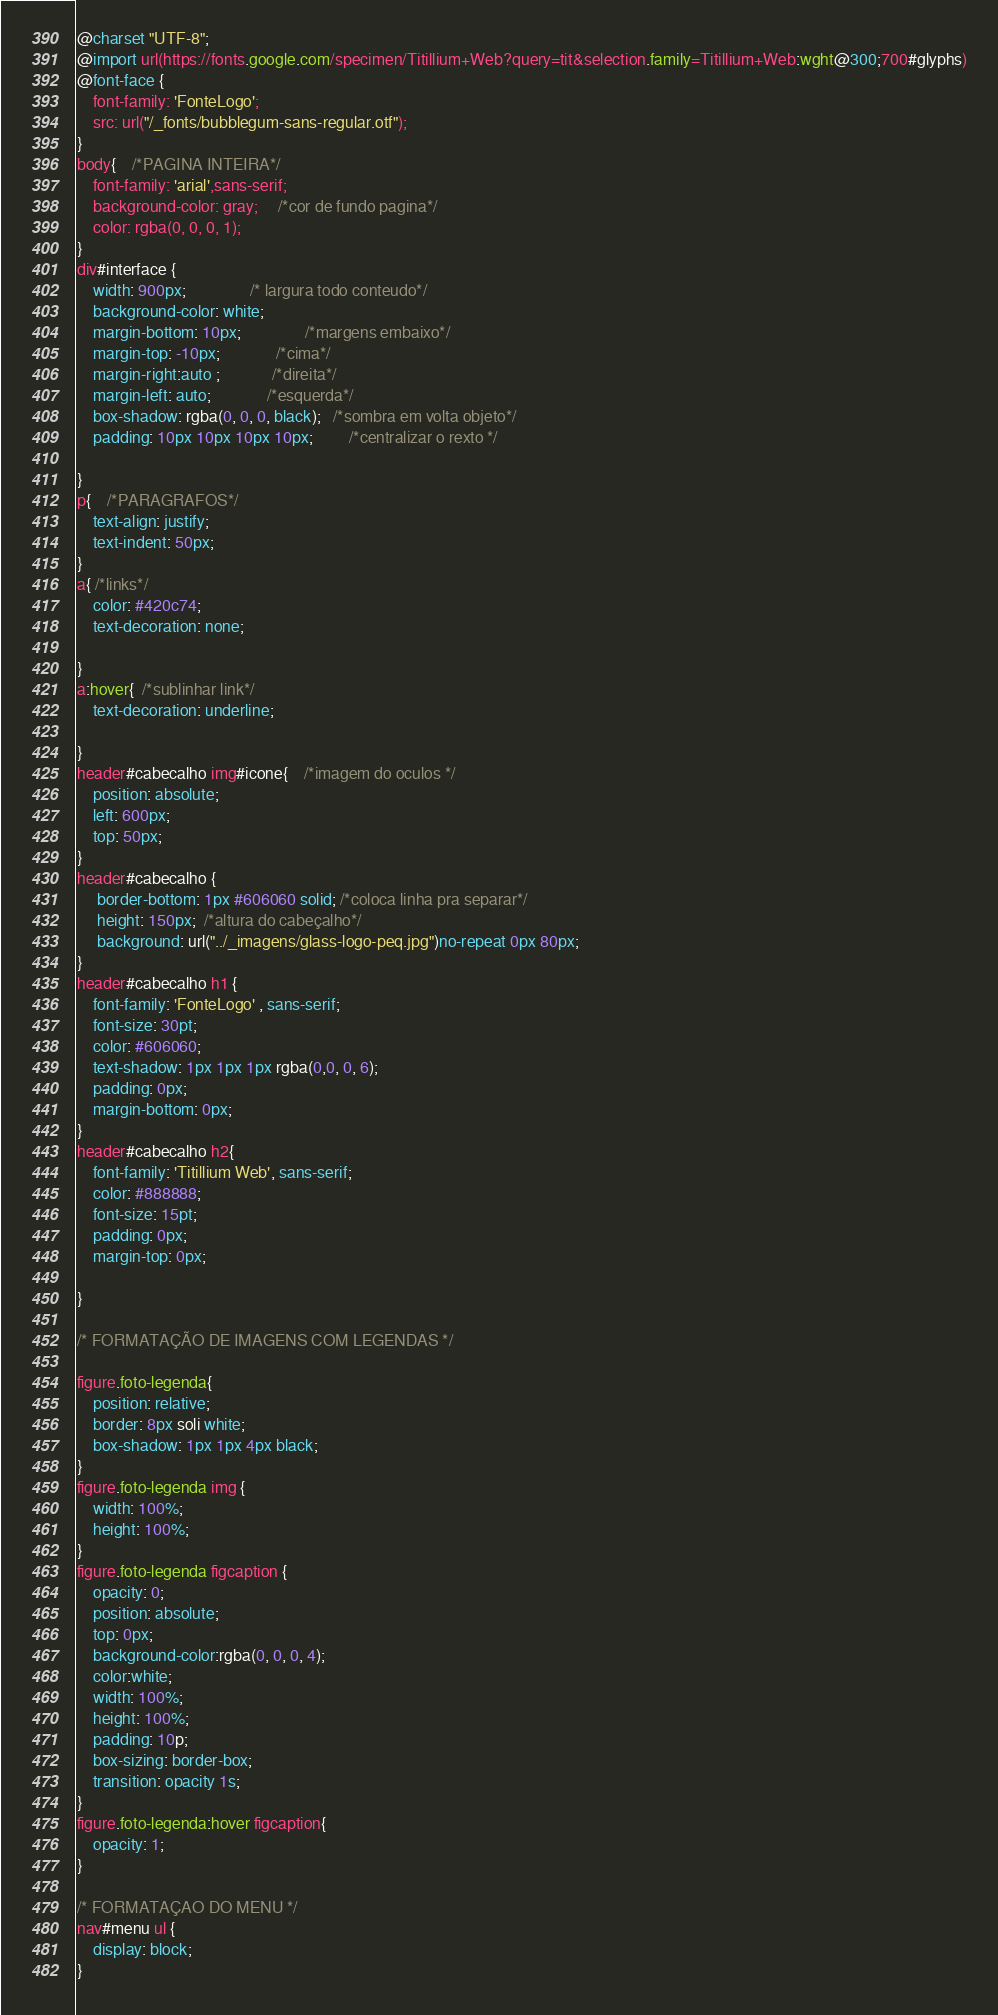<code> <loc_0><loc_0><loc_500><loc_500><_CSS_>@charset "UTF-8";
@import url(https://fonts.google.com/specimen/Titillium+Web?query=tit&selection.family=Titillium+Web:wght@300;700#glyphs)
@font-face {
    font-family: 'FonteLogo';
    src: url("/_fonts/bubblegum-sans-regular.otf");
}
body{	/*PAGINA INTEIRA*/
    font-family: 'arial',sans-serif;					
    background-color: gray;     /*cor de fundo pagina*/
    color: rgba(0, 0, 0, 1);
}
div#interface {         
    width: 900px;                /* largura todo conteudo*/
    background-color: white;   
    margin-bottom: 10px;                /*margens embaixo*/
    margin-top: -10px;              /*cima*/ 
    margin-right:auto ;             /*direita*/ 
    margin-left: auto;              /*esquerda*/
    box-shadow: rgba(0, 0, 0, black);   /*sombra em volta objeto*/
    padding: 10px 10px 10px 10px;         /*centralizar o rexto */
    
}   
p{    /*PARAGRAFOS*/
    text-align: justify;
    text-indent: 50px;
}
a{ /*links*/
    color: #420c74;
    text-decoration: none;

}
a:hover{  /*sublinhar link*/
    text-decoration: underline;

}
header#cabecalho img#icone{    /*imagem do oculos */
    position: absolute;
    left: 600px;
    top: 50px;
}
header#cabecalho {
     border-bottom: 1px #606060 solid; /*coloca linha pra separar*/
     height: 150px;  /*altura do cabeçalho*/
     background: url("../_imagens/glass-logo-peq.jpg")no-repeat 0px 80px;
}
header#cabecalho h1 {  
    font-family: 'FonteLogo' , sans-serif;
    font-size: 30pt;
    color: #606060;
    text-shadow: 1px 1px 1px rgba(0,0, 0, 6);
    padding: 0px;
    margin-bottom: 0px;
}
header#cabecalho h2{
    font-family: 'Titillium Web', sans-serif;
    color: #888888;
    font-size: 15pt;
    padding: 0px;
    margin-top: 0px;

}

/* FORMATAÇÃO DE IMAGENS COM LEGENDAS */

figure.foto-legenda{
    position: relative;
    border: 8px soli white;
    box-shadow: 1px 1px 4px black;  
}
figure.foto-legenda img {
    width: 100%;
    height: 100%;
}
figure.foto-legenda figcaption {
    opacity: 0;
    position: absolute;
    top: 0px;
    background-color:rgba(0, 0, 0, 4);
    color:white;
    width: 100%;
    height: 100%;
    padding: 10p;
    box-sizing: border-box;
    transition: opacity 1s;
}
figure.foto-legenda:hover figcaption{
    opacity: 1;
}
   
/* FORMATAÇAO DO MENU */
nav#menu ul {
    display: block;
}
</code> 